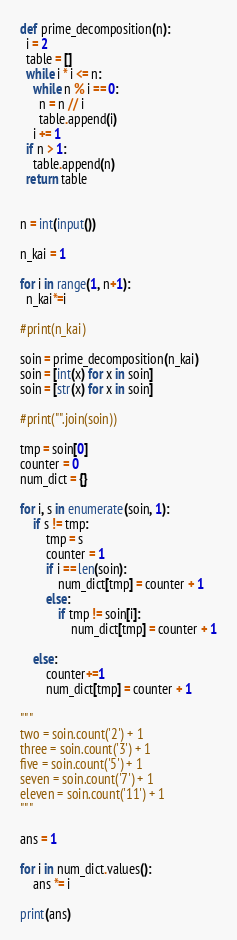Convert code to text. <code><loc_0><loc_0><loc_500><loc_500><_Python_>
def prime_decomposition(n):
  i = 2
  table = []
  while i * i <= n:
    while n % i == 0:
      n = n // i
      table.append(i)
    i += 1
  if n > 1:
    table.append(n)
  return table


n = int(input())

n_kai = 1

for i in range(1, n+1):
  n_kai*=i

#print(n_kai)

soin = prime_decomposition(n_kai)
soin = [int(x) for x in soin]
soin = [str(x) for x in soin]

#print("".join(soin))

tmp = soin[0]
counter = 0
num_dict = {}

for i, s in enumerate(soin, 1):
    if s != tmp:
        tmp = s
        counter = 1
        if i == len(soin):
            num_dict[tmp] = counter + 1
        else:
            if tmp != soin[i]:
                num_dict[tmp] = counter + 1

    else:
        counter+=1
        num_dict[tmp] = counter + 1

"""
two = soin.count('2') + 1
three = soin.count('3') + 1
five = soin.count('5') + 1
seven = soin.count('7') + 1
eleven = soin.count('11') + 1
"""

ans = 1

for i in num_dict.values():
    ans *= i

print(ans)

</code> 